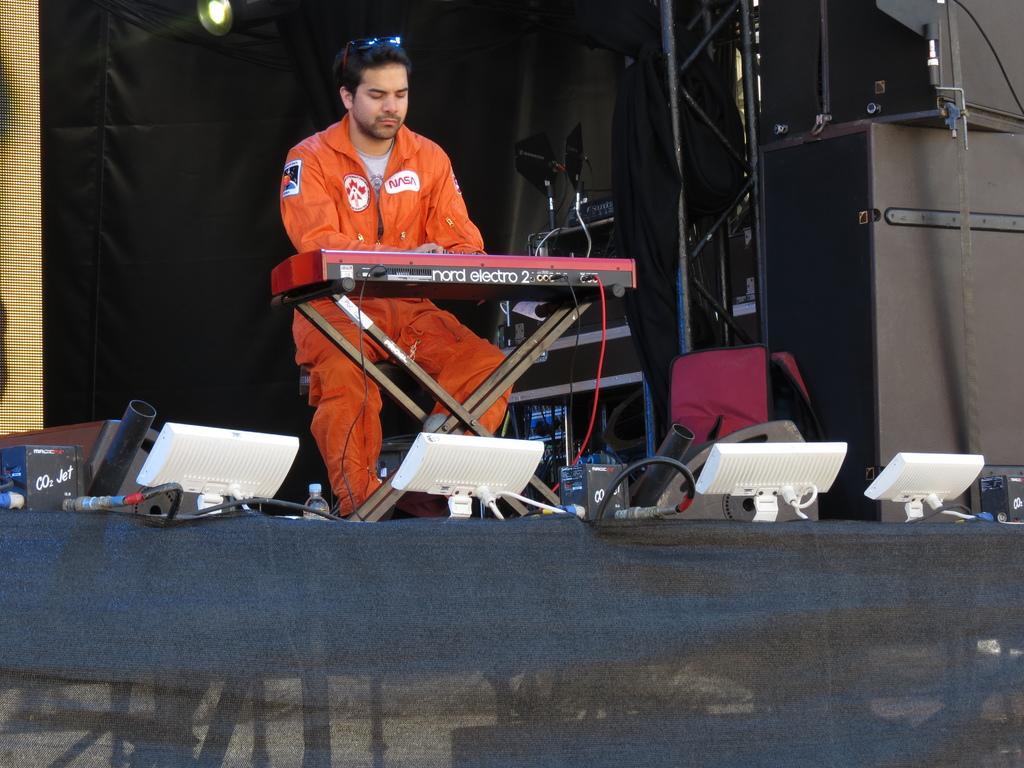Can you describe this image briefly? In this picture there is a man who is wearing orange dress. He is sitting on the chair and the playing the piano. In the center we can see the speakers, cables and white object. In the background we can see the black cloth. At the top there is a light. 